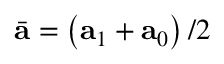<formula> <loc_0><loc_0><loc_500><loc_500>\bar { a } = \left ( a _ { 1 } + a _ { 0 } \right ) / 2</formula> 